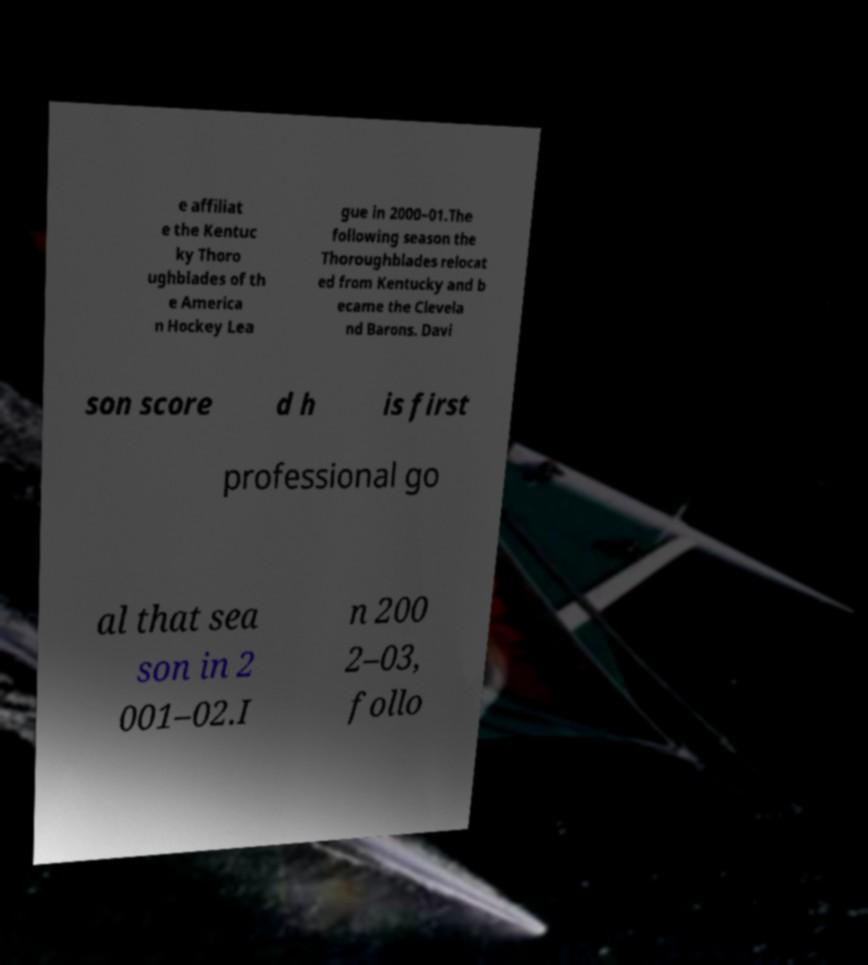For documentation purposes, I need the text within this image transcribed. Could you provide that? e affiliat e the Kentuc ky Thoro ughblades of th e America n Hockey Lea gue in 2000–01.The following season the Thoroughblades relocat ed from Kentucky and b ecame the Clevela nd Barons. Davi son score d h is first professional go al that sea son in 2 001–02.I n 200 2–03, follo 